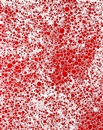How might the technique used here influence the viewer's perception of the artwork? The use of pointillism in this artwork creates a mosaic of vibrant dots that blend from a distance yet stand distinct up close, engaging viewers in a visual dance. This duality can influence the perception by offering different experiences at various distances, thus inviting viewers to explore and interact with the art on multiple levels, enhancing their engagement and appreciation. 